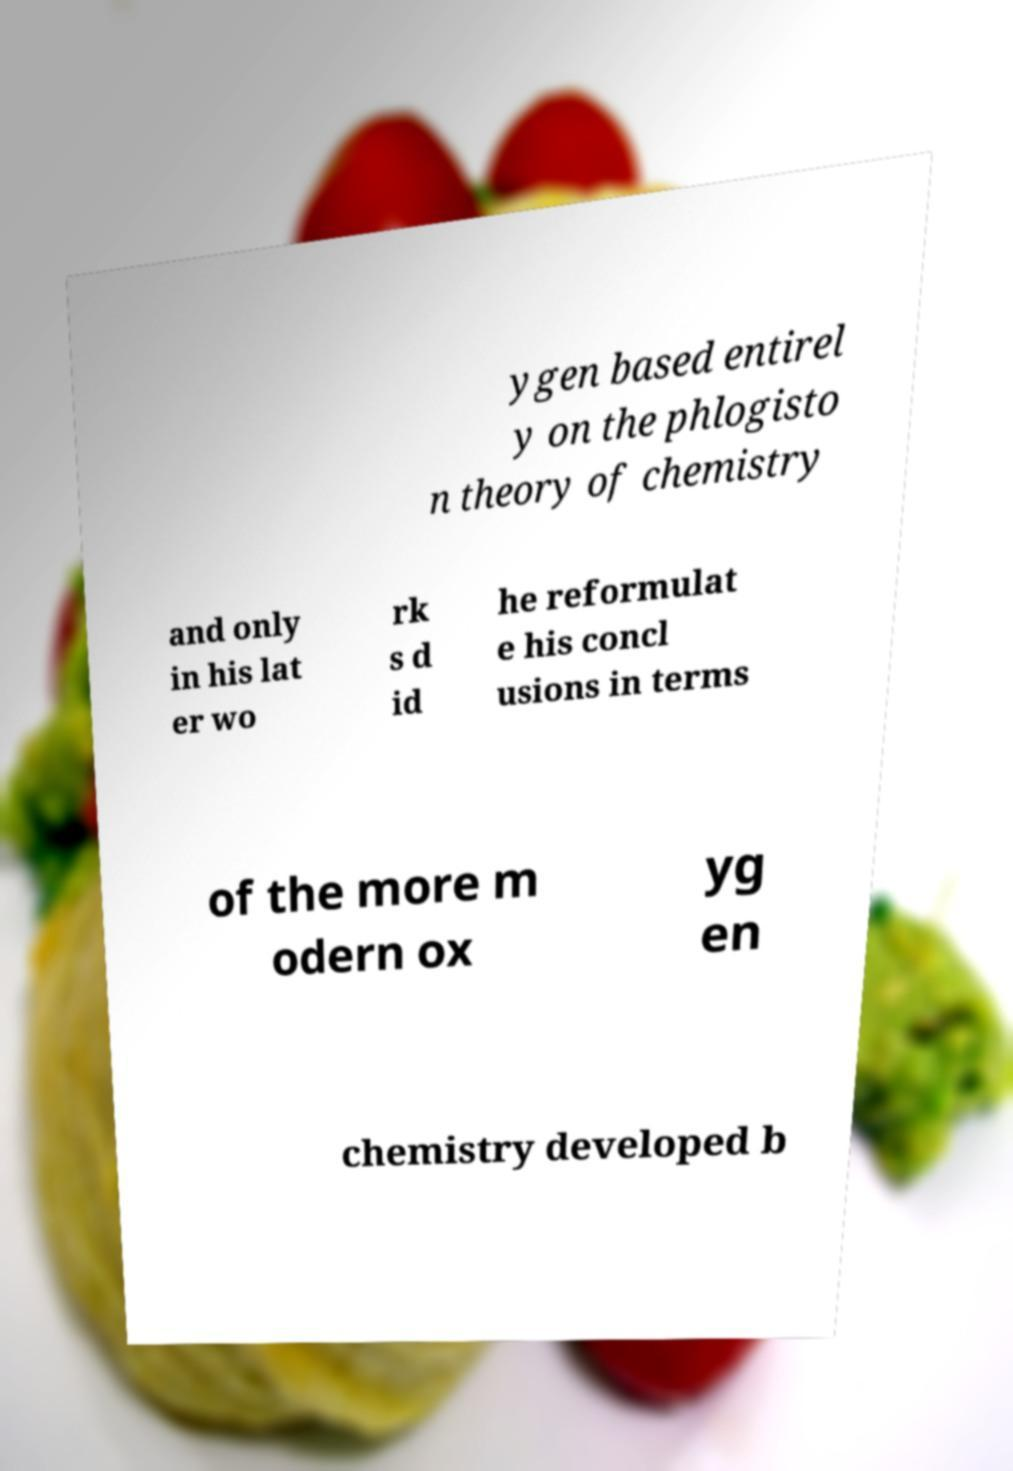I need the written content from this picture converted into text. Can you do that? ygen based entirel y on the phlogisto n theory of chemistry and only in his lat er wo rk s d id he reformulat e his concl usions in terms of the more m odern ox yg en chemistry developed b 